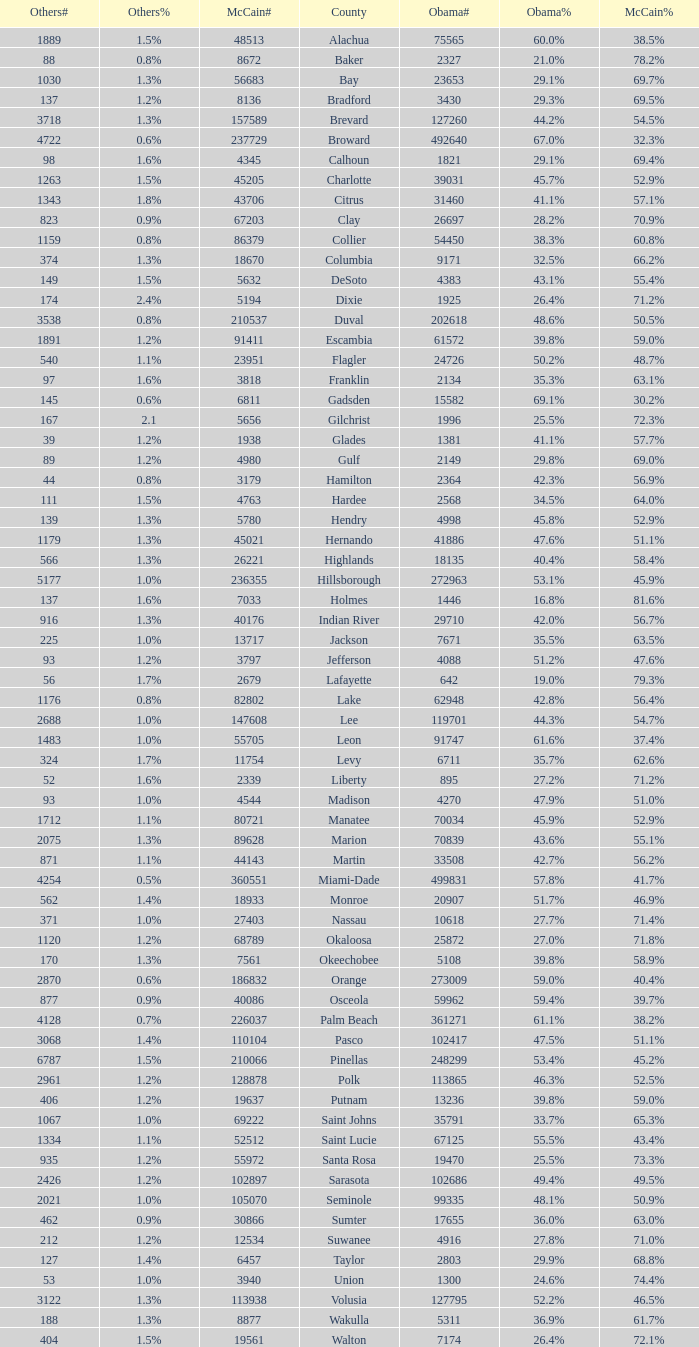What was the number of others votes in Columbia county? 374.0. 